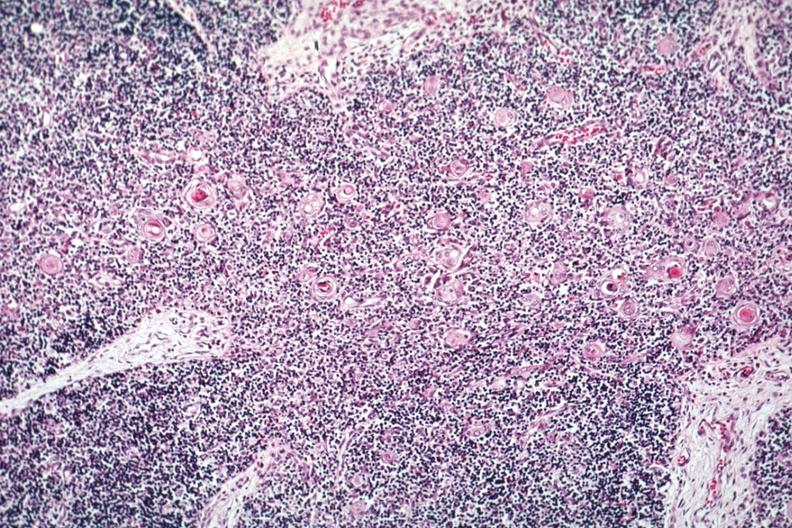s spina bifida present?
Answer the question using a single word or phrase. No 